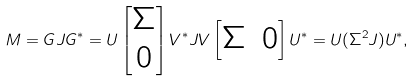<formula> <loc_0><loc_0><loc_500><loc_500>M = G J G ^ { \ast } = U \begin{bmatrix} \Sigma \\ 0 \end{bmatrix} V ^ { \ast } J V \begin{bmatrix} \Sigma & 0 \end{bmatrix} U ^ { \ast } = U ( \Sigma ^ { 2 } J ) U ^ { \ast } ,</formula> 